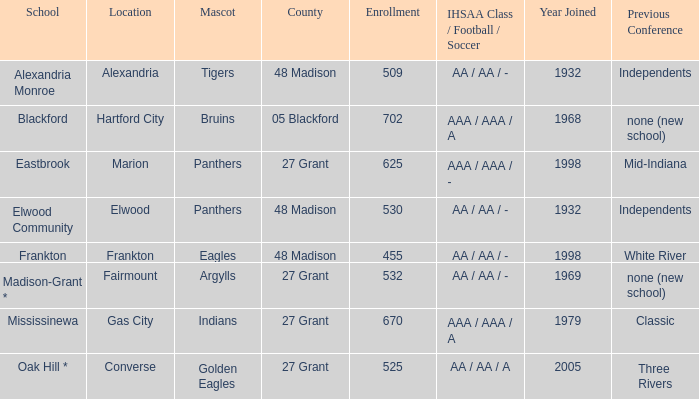What is the school with the location of alexandria? Alexandria Monroe. 